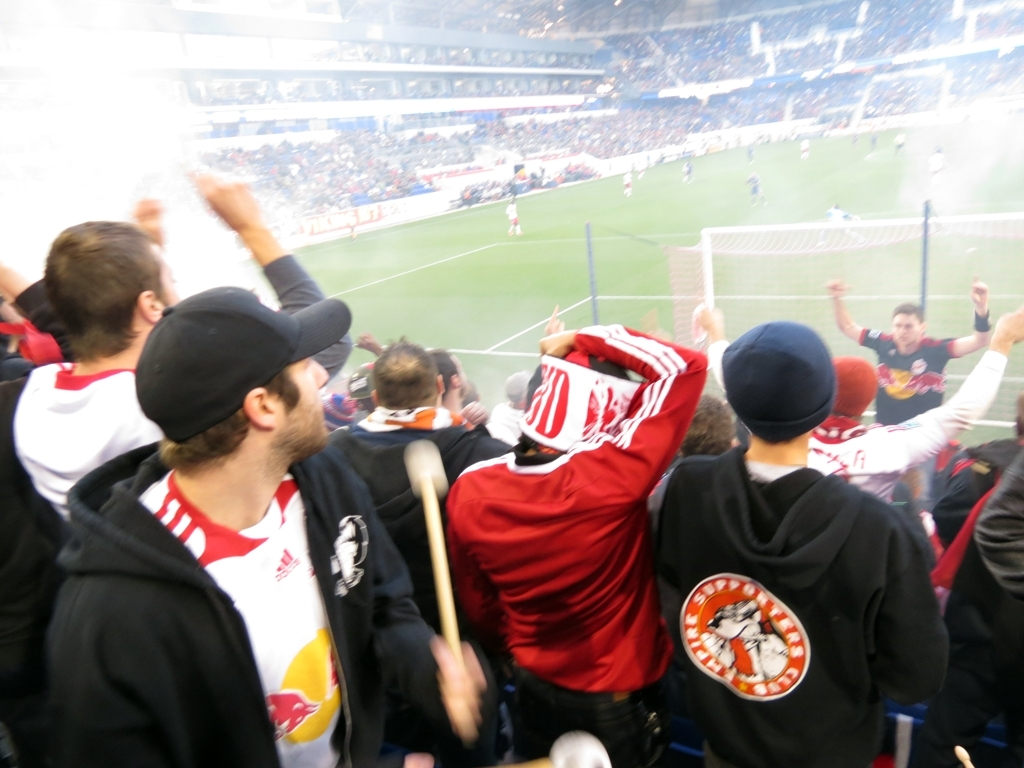Can you describe the atmosphere in the picture? The image captures a dynamic and exciting sporting event atmosphere, depicting fans in intense celebration, likely after a critical moment like a goal. The blurred effect, although unintentional, also adds to the sense of movement and fervor. 